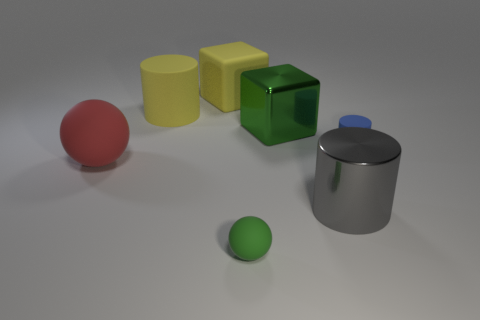Subtract all large matte cylinders. How many cylinders are left? 2 Add 2 green rubber things. How many objects exist? 9 Subtract 1 cylinders. How many cylinders are left? 2 Subtract all spheres. How many objects are left? 5 Subtract all red cylinders. Subtract all cyan balls. How many cylinders are left? 3 Add 7 large cylinders. How many large cylinders exist? 9 Subtract 0 brown blocks. How many objects are left? 7 Subtract all yellow cubes. Subtract all small spheres. How many objects are left? 5 Add 1 red matte balls. How many red matte balls are left? 2 